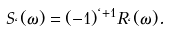Convert formula to latex. <formula><loc_0><loc_0><loc_500><loc_500>S _ { \ell } ( \omega ) = ( - 1 ) ^ { \ell + 1 } R _ { \ell } ( \omega ) .</formula> 